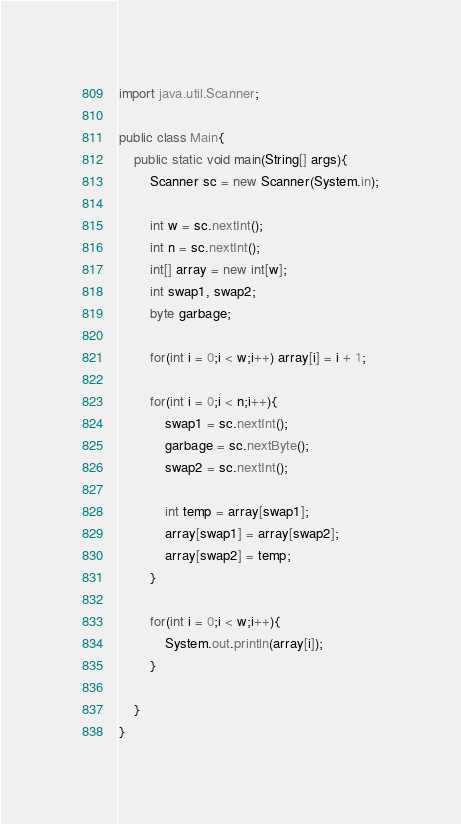Convert code to text. <code><loc_0><loc_0><loc_500><loc_500><_Java_>import java.util.Scanner;

public class Main{
	public static void main(String[] args){
		Scanner sc = new Scanner(System.in);

		int w = sc.nextInt();
		int n = sc.nextInt();
		int[] array = new int[w];
		int swap1, swap2;
		byte garbage;

		for(int i = 0;i < w;i++) array[i] = i + 1;

		for(int i = 0;i < n;i++){
			swap1 = sc.nextInt();
			garbage = sc.nextByte();
			swap2 = sc.nextInt();

			int temp = array[swap1];
			array[swap1] = array[swap2];
			array[swap2] = temp;
		}

		for(int i = 0;i < w;i++){
			System.out.println(array[i]);
		}

	}
}
</code> 